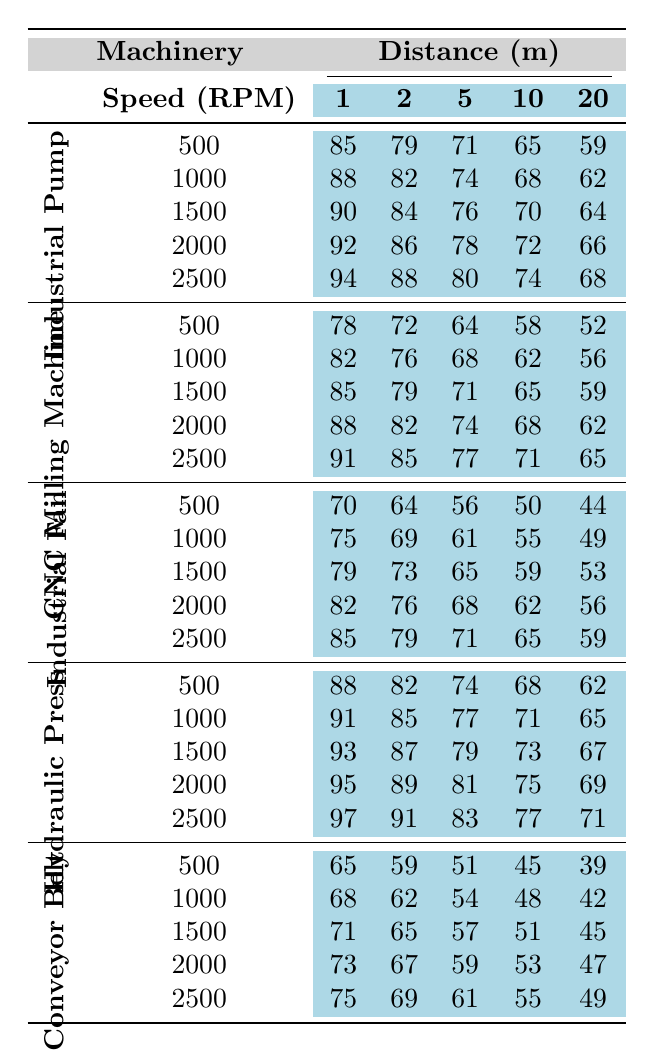What is the decibel level of the Industrial Fan at a distance of 5 meters and a speed of 1000 RPM? From the table, locate the row for the Industrial Fan and find the column for 5 meters at 1000 RPM. The decibel level is 61.
Answer: 61 How does the decibel level of the Hydraulic Press at a speed of 1500 RPM compare to that at 2000 RPM at a distance of 10 meters? Looking at the table, the decibel levels for the Hydraulic Press at 1500 RPM and 2000 RPM at 10 meters are 73 and 75, respectively. The comparison shows that 75 is higher than 73.
Answer: Higher What is the difference in decibel levels between the Conveyor Belt and the Industrial Pump at a speed of 500 RPM and a distance of 1 meter? For the Conveyor Belt, the decibel level at 500 RPM and 1 meter is 65. For the Industrial Pump, it is 85. The difference is 85 - 65 = 20.
Answer: 20 What is the average decibel level of the CNC Milling Machine across all speeds at a distance of 2 meters? The CNC Milling Machine decibel levels at 2 meters are 72, 76, 79, 82, and 85. Adding these gives 394, and then dividing by the number of speeds (5) gives an average of 394/5 = 78.8.
Answer: 78.8 Is the decibel level of the Industrial Fan at a distance of 10 meters greater than that of the Conveyor Belt at the same distance? Check the Industrial Fan's decibel level at 10 meters, which is 62, and the Conveyor Belt's, which is 53. Since 62 is greater than 53, the answer is yes.
Answer: Yes What is the highest decibel level recorded among all machinery at a distance of 20 meters? Locate the table's last column for each machinery category at 20 meters: Industrial Pump (68), CNC Milling Machine (65), Industrial Fan (59), Hydraulic Press (71), and Conveyor Belt (49). The highest value is 71 from the Hydraulic Press.
Answer: 71 Which machinery, when operating at 2000 RPM, is the quietest at a distance of 1 meter? Check the 2000 RPM row across all machinery for the 1 meter column: Industrial Pump (92), CNC Milling Machine (88), Industrial Fan (82), Hydraulic Press (95), and Conveyor Belt (73). The lowest is 73 from the Conveyor Belt.
Answer: Conveyor Belt What is the trend of decibel levels for the Industrial Pump as the distance increases from 1 meter to 20 meters? The decibel levels for the Industrial Pump at increasing distances are 85 at 1 meter, decreasing to 59 at 20 meters. The trend is consistently decreasing.
Answer: Decreasing At which speed does the Industrial Fan exhibit its highest decibel level? Review the Industrial Fan's decibel levels for each speed: 500 RPM (70), 1000 RPM (75), 1500 RPM (79), 2000 RPM (82), and 2500 RPM (85). The highest is at 2500 RPM.
Answer: 2500 RPM What are the decibel levels for the CNC Milling Machine at 1000 RPM and 5 meters? Looking at the table, the values for the CNC Milling Machine at 1000 RPM and 5 meters is 68.
Answer: 68 